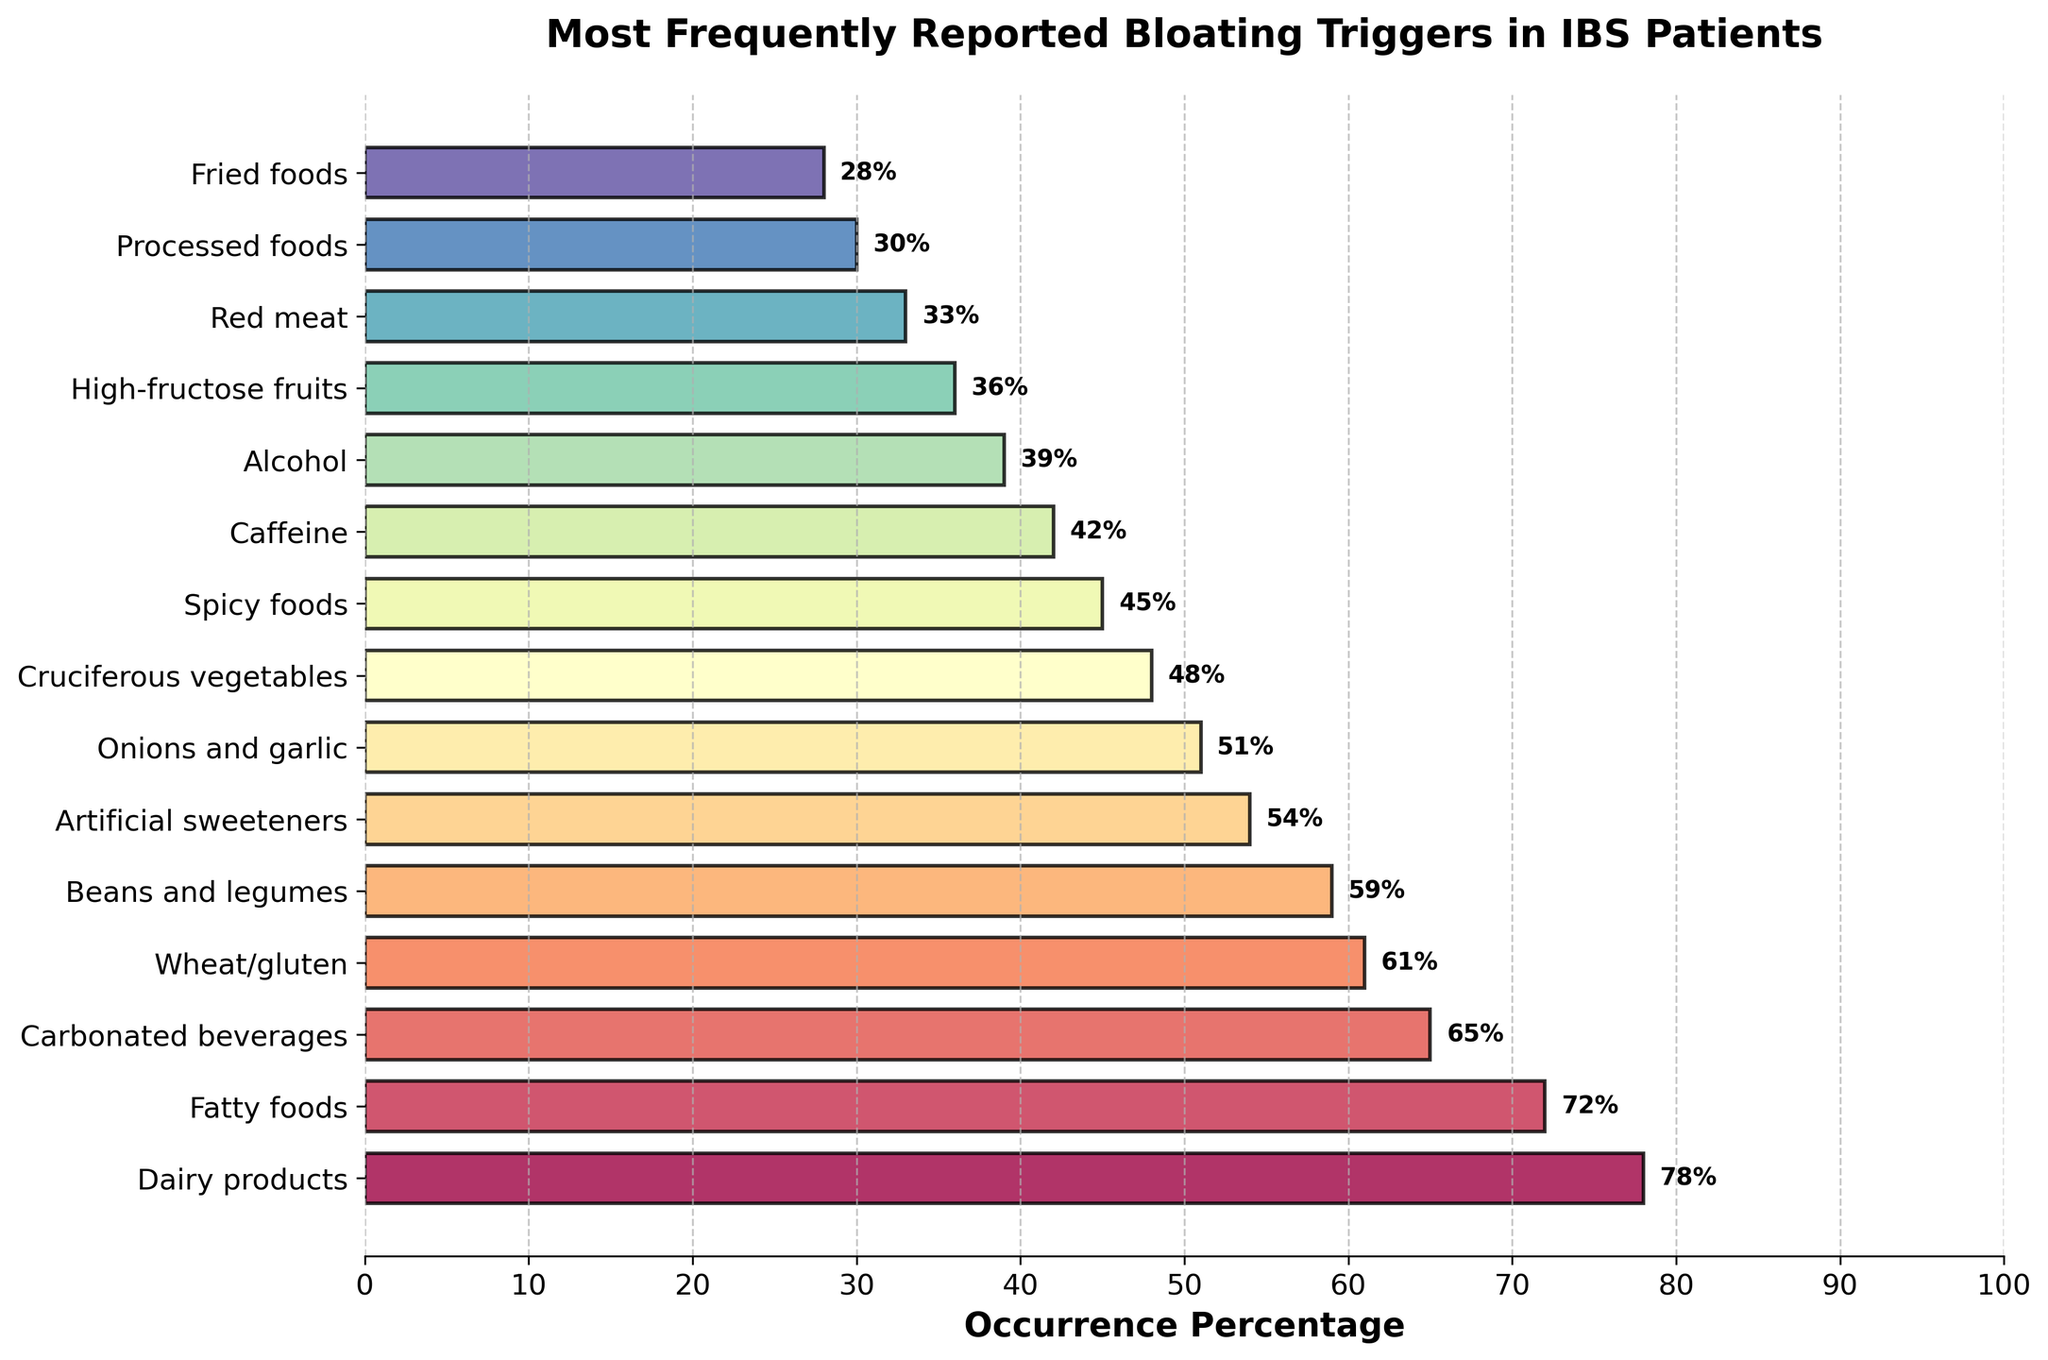Which bloating trigger has the highest reported occurrence? The bar chart shows various bloating triggers with their reported occurrence percentages. The bar for dairy products is the longest, indicating it has the highest percentage.
Answer: Dairy products Which bloating trigger has the lowest reported occurrence? By observing the lengths of the bars, the bar for fried foods is the shortest, showing the lowest percentage.
Answer: Fried foods What is the total occurrence percentage of the top three triggers? The top three triggers by occurrence percentage are Dairy products (78%), Fatty foods (72%), and Carbonated beverages (65%). Summing these values: 78 + 72 + 65 = 215.
Answer: 215 How much higher is the occurrence percentage of Dairy products compared to Alcohol? The occurrence percentage for Dairy products is 78%, and for Alcohol, it's 39%. The difference is calculated as 78 - 39 = 39.
Answer: 39 Among the reported triggers, which ones lie between 40% and 60% occurrence? By looking at the chart, the bars that fall between 40% and 60% are Artificial sweeteners (54%), Onions and garlic (51%), Cruciferous vegetables (48%), Spicy foods (45%), and Caffeine (42%).
Answer: Artificial sweeteners, Onions and garlic, Cruciferous vegetables, Spicy foods, Caffeine Is the occurrence percentage of Carbonated beverages greater than that of Cruciferous vegetables? The occurrence percentage of Carbonated beverages is 65%, and that of Cruciferous vegetables is 48%. Since 65 > 48, the answer is yes.
Answer: Yes Out of the reported triggers, how many have an occurrence percentage above 50%? We need to count the number of bars with percentages above 50%. These are Dairy products (78%), Fatty foods (72%), Carbonated beverages (65%), Wheat/gluten (61%), Beans and legumes (59%), and Artificial sweeteners (54%), and Onions and garlic (51%). So, there are 7 triggers.
Answer: 7 How much lower is the occurrence of Fried foods compared to Spicy foods? The occurrence of Fried foods is 28%, and for Spicy foods, it is 45%. The difference is calculated as 45 - 28 = 17.
Answer: 17 Which color gradient is used to represent the bars? The colors of the bars transition through various hues, indicating that a spectral color gradient is used.
Answer: Spectral gradient 